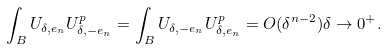<formula> <loc_0><loc_0><loc_500><loc_500>\int _ { B } U _ { \delta , e _ { n } } U _ { \delta , - e _ { n } } ^ { p } = \int _ { B } U _ { \delta , - e _ { n } } U _ { \delta , e _ { n } } ^ { p } = O ( \delta ^ { n - 2 } ) \delta \to 0 ^ { + } .</formula> 